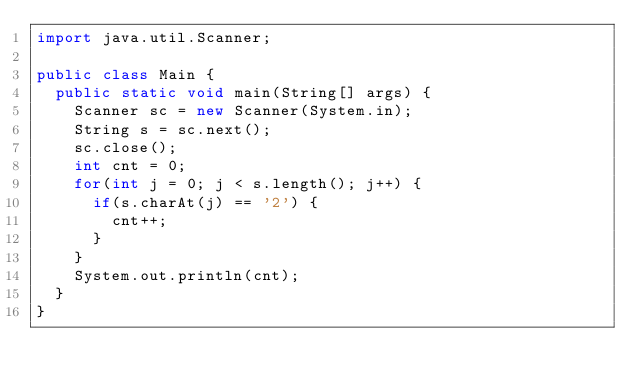<code> <loc_0><loc_0><loc_500><loc_500><_Java_>import java.util.Scanner;

public class Main {
	public static void main(String[] args) {
		Scanner sc = new Scanner(System.in);
		String s = sc.next();
		sc.close();
		int cnt = 0;
		for(int j = 0; j < s.length(); j++) {
			if(s.charAt(j) == '2') {
				cnt++;
			}
		}
		System.out.println(cnt);
	}
}</code> 